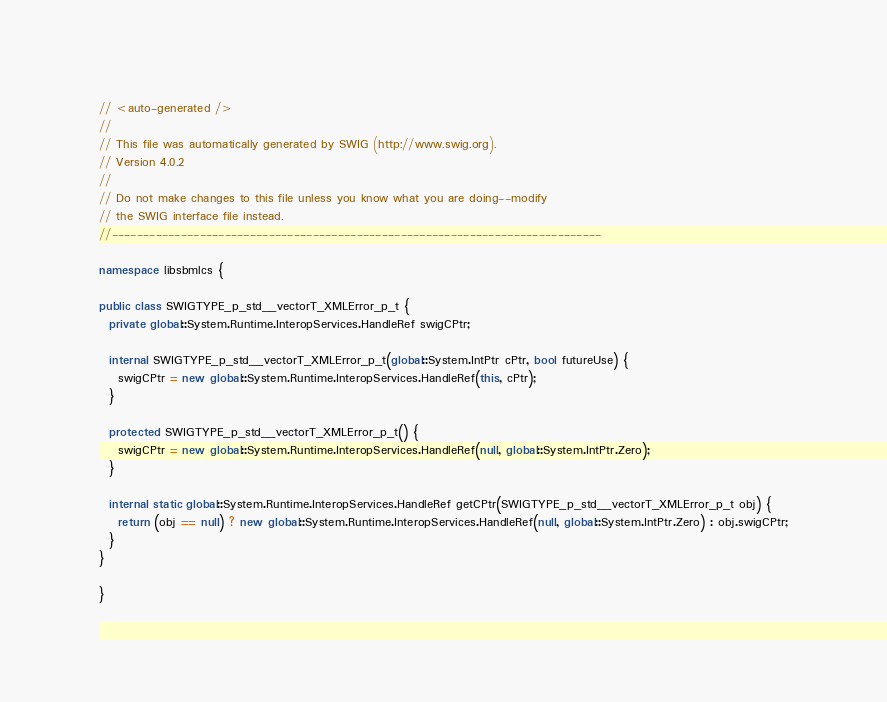Convert code to text. <code><loc_0><loc_0><loc_500><loc_500><_C#_>// <auto-generated />
//
// This file was automatically generated by SWIG (http://www.swig.org).
// Version 4.0.2
//
// Do not make changes to this file unless you know what you are doing--modify
// the SWIG interface file instead.
//------------------------------------------------------------------------------

namespace libsbmlcs {

public class SWIGTYPE_p_std__vectorT_XMLError_p_t {
  private global::System.Runtime.InteropServices.HandleRef swigCPtr;

  internal SWIGTYPE_p_std__vectorT_XMLError_p_t(global::System.IntPtr cPtr, bool futureUse) {
    swigCPtr = new global::System.Runtime.InteropServices.HandleRef(this, cPtr);
  }

  protected SWIGTYPE_p_std__vectorT_XMLError_p_t() {
    swigCPtr = new global::System.Runtime.InteropServices.HandleRef(null, global::System.IntPtr.Zero);
  }

  internal static global::System.Runtime.InteropServices.HandleRef getCPtr(SWIGTYPE_p_std__vectorT_XMLError_p_t obj) {
    return (obj == null) ? new global::System.Runtime.InteropServices.HandleRef(null, global::System.IntPtr.Zero) : obj.swigCPtr;
  }
}

}
</code> 